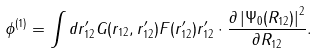<formula> <loc_0><loc_0><loc_500><loc_500>\phi ^ { ( 1 ) } = \int { d { r } ^ { \prime } _ { 1 2 } G ( { r } _ { 1 2 } , { r } ^ { \prime } _ { 1 2 } ) } F ( { r } ^ { \prime } _ { 1 2 } ) { r } ^ { \prime } _ { 1 2 } \cdot \frac { { \partial \left | { \Psi _ { 0 } ( { R } _ { 1 2 } ) } \right | ^ { 2 } } } { { \partial { R } _ { 1 2 } } } .</formula> 